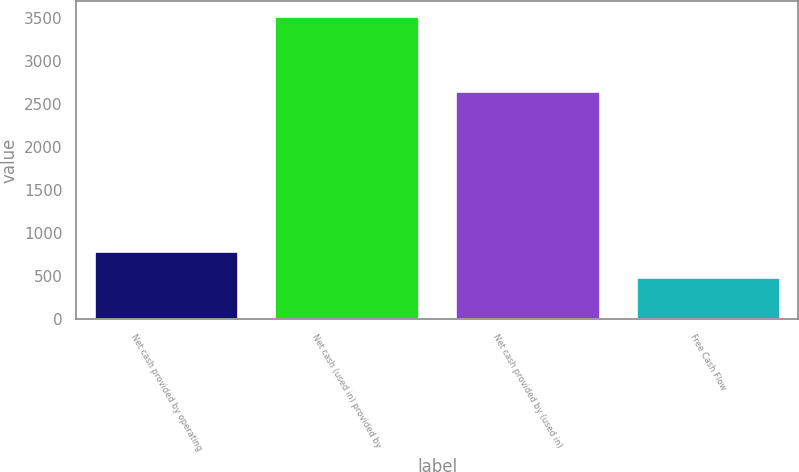Convert chart to OTSL. <chart><loc_0><loc_0><loc_500><loc_500><bar_chart><fcel>Net cash provided by operating<fcel>Net cash (used in) provided by<fcel>Net cash provided by (used in)<fcel>Free Cash Flow<nl><fcel>790.59<fcel>3522<fcel>2650.1<fcel>487.1<nl></chart> 